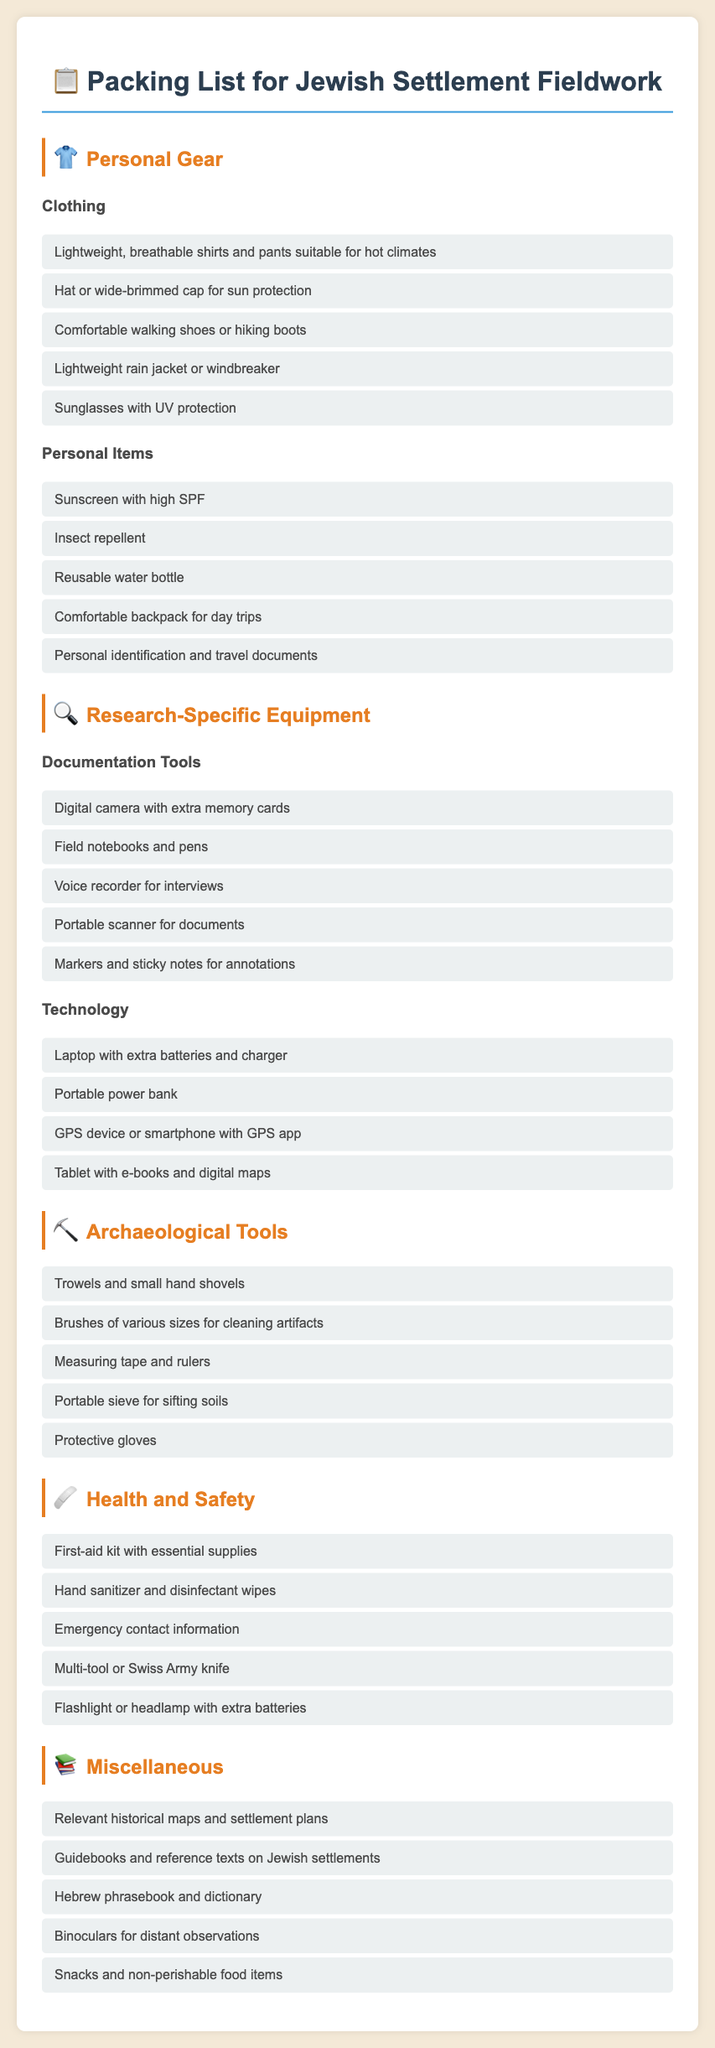what is the title of the document? The title of the document, as indicated in the header, is the Packing List for Jewish Settlement Fieldwork.
Answer: Packing List for Jewish Settlement Fieldwork how many categories of items are listed? The document has five main categories: Personal Gear, Research-Specific Equipment, Archaeological Tools, Health and Safety, and Miscellaneous.
Answer: Five which item is suggested for sun protection? The document includes a hat or wide-brimmed cap specifically for sun protection.
Answer: Hat or wide-brimmed cap what technology is recommended for navigation? The document recommends a GPS device or smartphone with a GPS app for navigation purposes.
Answer: GPS device or smartphone with GPS app how many personal items are mentioned? The personal items section lists five items required for individuals during fieldwork.
Answer: Five what tool is specifically used for sifting soils? The document states that a portable sieve should be used for sifting soils.
Answer: Portable sieve which document category includes health supplies? The Health and Safety category specifically addresses health supplies needed for fieldwork.
Answer: Health and Safety what is a suggested item for cleaning artifacts? The document suggests brushes of various sizes for cleaning artifacts.
Answer: Brushes of various sizes 